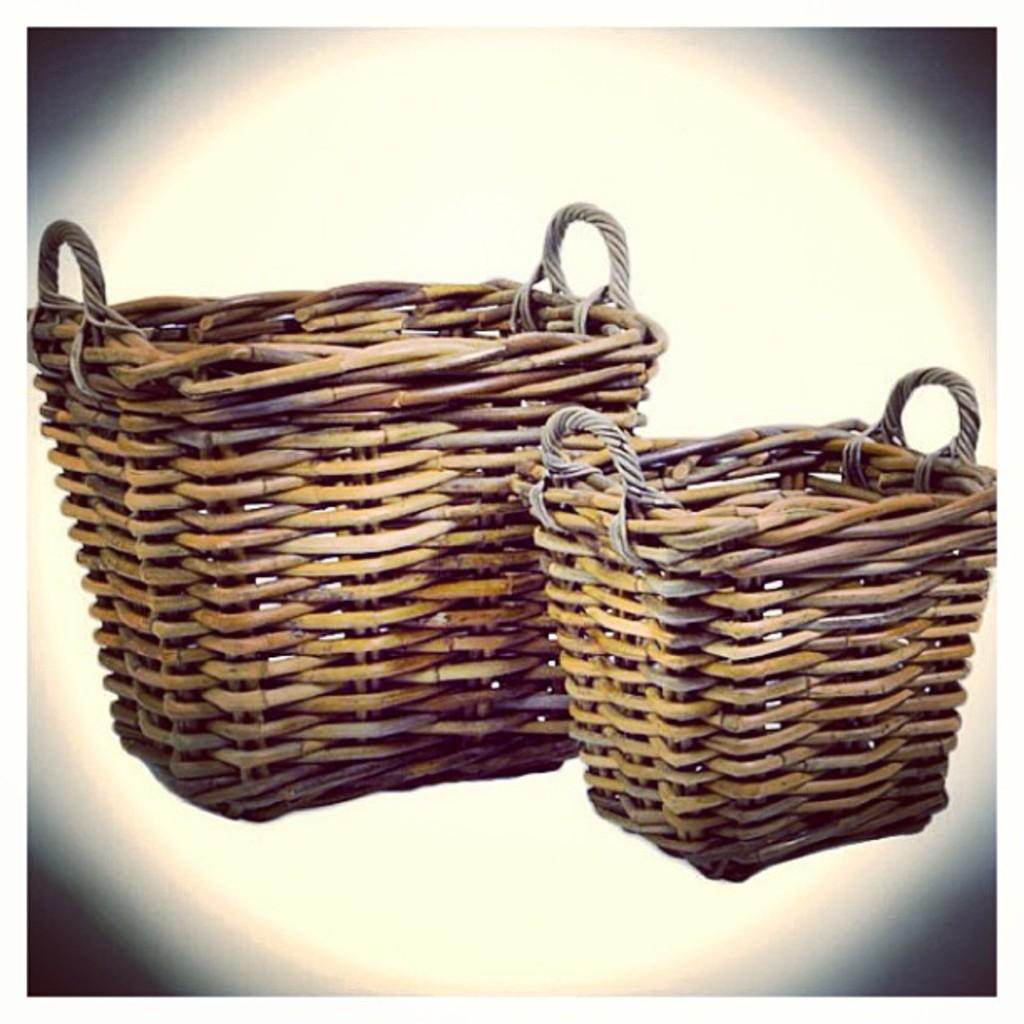How many baskets are present in the image? There are two baskets in the image. What feature do the baskets have in common? Each basket has handles. What type of flower is growing out of the baskets in the image? There are no flowers present in the image; it only features two baskets with handles. What financial interest might the baskets have in the image? The image does not provide any information about financial interests or a beggar, as it only shows two baskets with handles. 